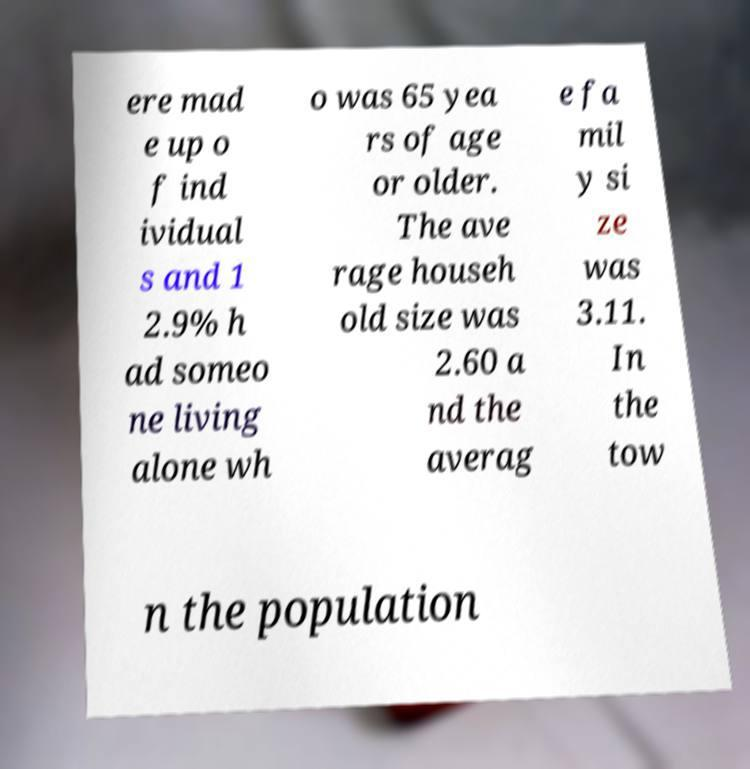I need the written content from this picture converted into text. Can you do that? ere mad e up o f ind ividual s and 1 2.9% h ad someo ne living alone wh o was 65 yea rs of age or older. The ave rage househ old size was 2.60 a nd the averag e fa mil y si ze was 3.11. In the tow n the population 